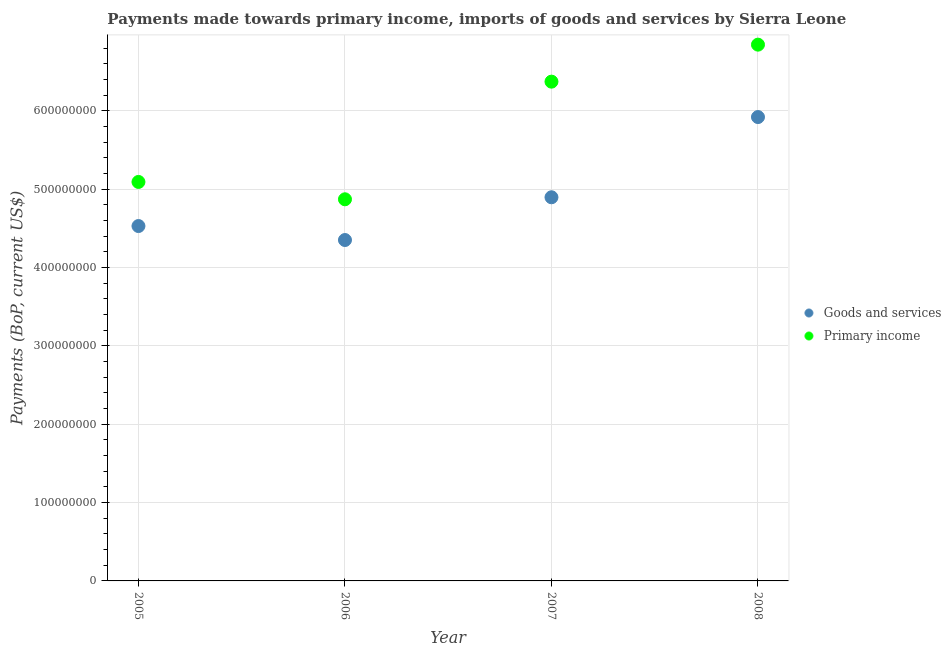How many different coloured dotlines are there?
Ensure brevity in your answer.  2. What is the payments made towards goods and services in 2008?
Your answer should be compact. 5.92e+08. Across all years, what is the maximum payments made towards primary income?
Offer a very short reply. 6.85e+08. Across all years, what is the minimum payments made towards primary income?
Give a very brief answer. 4.87e+08. In which year was the payments made towards primary income maximum?
Give a very brief answer. 2008. What is the total payments made towards goods and services in the graph?
Ensure brevity in your answer.  1.97e+09. What is the difference between the payments made towards primary income in 2005 and that in 2008?
Give a very brief answer. -1.75e+08. What is the difference between the payments made towards primary income in 2007 and the payments made towards goods and services in 2006?
Provide a succinct answer. 2.02e+08. What is the average payments made towards goods and services per year?
Offer a very short reply. 4.93e+08. In the year 2005, what is the difference between the payments made towards primary income and payments made towards goods and services?
Offer a terse response. 5.63e+07. What is the ratio of the payments made towards primary income in 2006 to that in 2008?
Provide a short and direct response. 0.71. Is the payments made towards primary income in 2005 less than that in 2007?
Your answer should be compact. Yes. What is the difference between the highest and the second highest payments made towards goods and services?
Make the answer very short. 1.02e+08. What is the difference between the highest and the lowest payments made towards goods and services?
Keep it short and to the point. 1.57e+08. Is the sum of the payments made towards primary income in 2005 and 2007 greater than the maximum payments made towards goods and services across all years?
Make the answer very short. Yes. Does the payments made towards primary income monotonically increase over the years?
Your response must be concise. No. Is the payments made towards primary income strictly less than the payments made towards goods and services over the years?
Provide a succinct answer. No. How many dotlines are there?
Give a very brief answer. 2. How many years are there in the graph?
Provide a succinct answer. 4. Does the graph contain any zero values?
Provide a succinct answer. No. How many legend labels are there?
Offer a terse response. 2. How are the legend labels stacked?
Ensure brevity in your answer.  Vertical. What is the title of the graph?
Provide a succinct answer. Payments made towards primary income, imports of goods and services by Sierra Leone. Does "Residents" appear as one of the legend labels in the graph?
Offer a very short reply. No. What is the label or title of the X-axis?
Your answer should be very brief. Year. What is the label or title of the Y-axis?
Keep it short and to the point. Payments (BoP, current US$). What is the Payments (BoP, current US$) in Goods and services in 2005?
Give a very brief answer. 4.53e+08. What is the Payments (BoP, current US$) of Primary income in 2005?
Your answer should be very brief. 5.09e+08. What is the Payments (BoP, current US$) in Goods and services in 2006?
Provide a short and direct response. 4.35e+08. What is the Payments (BoP, current US$) of Primary income in 2006?
Make the answer very short. 4.87e+08. What is the Payments (BoP, current US$) in Goods and services in 2007?
Provide a short and direct response. 4.90e+08. What is the Payments (BoP, current US$) of Primary income in 2007?
Offer a very short reply. 6.37e+08. What is the Payments (BoP, current US$) of Goods and services in 2008?
Offer a very short reply. 5.92e+08. What is the Payments (BoP, current US$) of Primary income in 2008?
Ensure brevity in your answer.  6.85e+08. Across all years, what is the maximum Payments (BoP, current US$) in Goods and services?
Make the answer very short. 5.92e+08. Across all years, what is the maximum Payments (BoP, current US$) of Primary income?
Make the answer very short. 6.85e+08. Across all years, what is the minimum Payments (BoP, current US$) in Goods and services?
Your answer should be compact. 4.35e+08. Across all years, what is the minimum Payments (BoP, current US$) of Primary income?
Provide a short and direct response. 4.87e+08. What is the total Payments (BoP, current US$) in Goods and services in the graph?
Give a very brief answer. 1.97e+09. What is the total Payments (BoP, current US$) of Primary income in the graph?
Your answer should be compact. 2.32e+09. What is the difference between the Payments (BoP, current US$) of Goods and services in 2005 and that in 2006?
Keep it short and to the point. 1.79e+07. What is the difference between the Payments (BoP, current US$) of Primary income in 2005 and that in 2006?
Give a very brief answer. 2.22e+07. What is the difference between the Payments (BoP, current US$) of Goods and services in 2005 and that in 2007?
Give a very brief answer. -3.67e+07. What is the difference between the Payments (BoP, current US$) in Primary income in 2005 and that in 2007?
Provide a succinct answer. -1.28e+08. What is the difference between the Payments (BoP, current US$) in Goods and services in 2005 and that in 2008?
Your answer should be compact. -1.39e+08. What is the difference between the Payments (BoP, current US$) of Primary income in 2005 and that in 2008?
Provide a succinct answer. -1.75e+08. What is the difference between the Payments (BoP, current US$) in Goods and services in 2006 and that in 2007?
Your answer should be very brief. -5.46e+07. What is the difference between the Payments (BoP, current US$) in Primary income in 2006 and that in 2007?
Give a very brief answer. -1.50e+08. What is the difference between the Payments (BoP, current US$) of Goods and services in 2006 and that in 2008?
Offer a very short reply. -1.57e+08. What is the difference between the Payments (BoP, current US$) of Primary income in 2006 and that in 2008?
Offer a terse response. -1.97e+08. What is the difference between the Payments (BoP, current US$) of Goods and services in 2007 and that in 2008?
Your answer should be very brief. -1.02e+08. What is the difference between the Payments (BoP, current US$) of Primary income in 2007 and that in 2008?
Provide a succinct answer. -4.72e+07. What is the difference between the Payments (BoP, current US$) in Goods and services in 2005 and the Payments (BoP, current US$) in Primary income in 2006?
Offer a terse response. -3.41e+07. What is the difference between the Payments (BoP, current US$) in Goods and services in 2005 and the Payments (BoP, current US$) in Primary income in 2007?
Your answer should be very brief. -1.84e+08. What is the difference between the Payments (BoP, current US$) in Goods and services in 2005 and the Payments (BoP, current US$) in Primary income in 2008?
Give a very brief answer. -2.32e+08. What is the difference between the Payments (BoP, current US$) in Goods and services in 2006 and the Payments (BoP, current US$) in Primary income in 2007?
Provide a succinct answer. -2.02e+08. What is the difference between the Payments (BoP, current US$) of Goods and services in 2006 and the Payments (BoP, current US$) of Primary income in 2008?
Provide a short and direct response. -2.49e+08. What is the difference between the Payments (BoP, current US$) of Goods and services in 2007 and the Payments (BoP, current US$) of Primary income in 2008?
Your answer should be very brief. -1.95e+08. What is the average Payments (BoP, current US$) in Goods and services per year?
Offer a very short reply. 4.93e+08. What is the average Payments (BoP, current US$) in Primary income per year?
Make the answer very short. 5.80e+08. In the year 2005, what is the difference between the Payments (BoP, current US$) in Goods and services and Payments (BoP, current US$) in Primary income?
Ensure brevity in your answer.  -5.63e+07. In the year 2006, what is the difference between the Payments (BoP, current US$) of Goods and services and Payments (BoP, current US$) of Primary income?
Keep it short and to the point. -5.20e+07. In the year 2007, what is the difference between the Payments (BoP, current US$) of Goods and services and Payments (BoP, current US$) of Primary income?
Provide a short and direct response. -1.48e+08. In the year 2008, what is the difference between the Payments (BoP, current US$) in Goods and services and Payments (BoP, current US$) in Primary income?
Ensure brevity in your answer.  -9.24e+07. What is the ratio of the Payments (BoP, current US$) in Goods and services in 2005 to that in 2006?
Your answer should be very brief. 1.04. What is the ratio of the Payments (BoP, current US$) in Primary income in 2005 to that in 2006?
Your answer should be very brief. 1.05. What is the ratio of the Payments (BoP, current US$) of Goods and services in 2005 to that in 2007?
Your answer should be very brief. 0.93. What is the ratio of the Payments (BoP, current US$) in Primary income in 2005 to that in 2007?
Your answer should be very brief. 0.8. What is the ratio of the Payments (BoP, current US$) in Goods and services in 2005 to that in 2008?
Provide a short and direct response. 0.77. What is the ratio of the Payments (BoP, current US$) of Primary income in 2005 to that in 2008?
Ensure brevity in your answer.  0.74. What is the ratio of the Payments (BoP, current US$) of Goods and services in 2006 to that in 2007?
Offer a terse response. 0.89. What is the ratio of the Payments (BoP, current US$) of Primary income in 2006 to that in 2007?
Keep it short and to the point. 0.76. What is the ratio of the Payments (BoP, current US$) in Goods and services in 2006 to that in 2008?
Keep it short and to the point. 0.73. What is the ratio of the Payments (BoP, current US$) in Primary income in 2006 to that in 2008?
Provide a short and direct response. 0.71. What is the ratio of the Payments (BoP, current US$) in Goods and services in 2007 to that in 2008?
Provide a succinct answer. 0.83. What is the difference between the highest and the second highest Payments (BoP, current US$) of Goods and services?
Make the answer very short. 1.02e+08. What is the difference between the highest and the second highest Payments (BoP, current US$) in Primary income?
Offer a very short reply. 4.72e+07. What is the difference between the highest and the lowest Payments (BoP, current US$) of Goods and services?
Give a very brief answer. 1.57e+08. What is the difference between the highest and the lowest Payments (BoP, current US$) in Primary income?
Make the answer very short. 1.97e+08. 